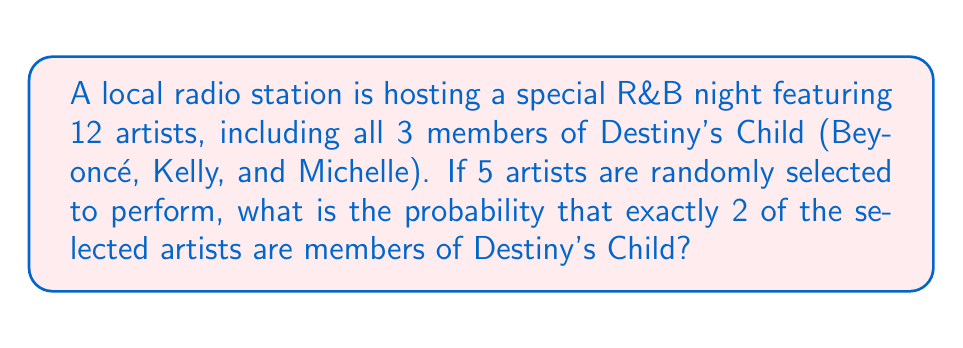Show me your answer to this math problem. Let's approach this step-by-step using the concept of combinations:

1) First, we need to calculate the total number of ways to select 5 artists out of 12. This is given by the combination formula:

   $$\binom{12}{5} = \frac{12!}{5!(12-5)!} = \frac{12!}{5!7!} = 792$$

2) Now, we need to calculate the number of ways to select exactly 2 Destiny's Child members and 3 other artists:

   a) Select 2 out of 3 Destiny's Child members: $\binom{3}{2} = 3$
   b) Select 3 out of the remaining 9 artists: $\binom{9}{3} = 84$

3) The total number of favorable outcomes is the product of these:

   $$3 \times 84 = 252$$

4) The probability is then the number of favorable outcomes divided by the total number of possible outcomes:

   $$P(\text{exactly 2 Destiny's Child members}) = \frac{252}{792} = \frac{9}{28} \approx 0.3214$$
Answer: $\frac{9}{28}$ or approximately 0.3214 or 32.14% 